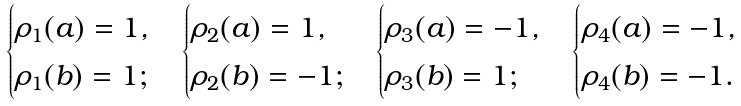<formula> <loc_0><loc_0><loc_500><loc_500>\begin{cases} \rho _ { 1 } ( a ) = 1 , \\ \rho _ { 1 } ( b ) = 1 ; \end{cases} \begin{cases} \rho _ { 2 } ( a ) = 1 , \\ \rho _ { 2 } ( b ) = - 1 ; \end{cases} \begin{cases} \rho _ { 3 } ( a ) = - 1 , \\ \rho _ { 3 } ( b ) = 1 ; \end{cases} \begin{cases} \rho _ { 4 } ( a ) = - 1 , \\ \rho _ { 4 } ( b ) = - 1 . \end{cases}</formula> 